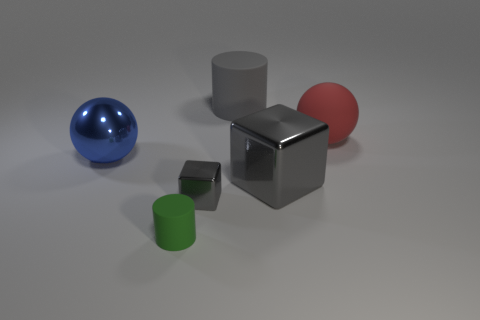There is a large rubber thing that is behind the red matte thing; what shape is it? The large rubber object behind the red matte sphere is a cylinder, characterized by its circular base and height extending perpendicular to the base, creating a shape that is symmetrical along its axis. 